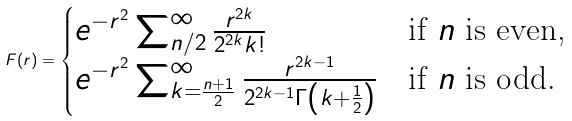<formula> <loc_0><loc_0><loc_500><loc_500>F ( r ) = \begin{cases} e ^ { - r ^ { 2 } } \sum _ { n / 2 } ^ { \infty } \frac { r ^ { 2 k } } { 2 ^ { 2 k } k ! } & \text {if $n$ is even,} \\ e ^ { - r ^ { 2 } } \sum _ { k = \frac { n + 1 } { 2 } } ^ { \infty } \frac { r ^ { 2 k - 1 } } { 2 ^ { 2 k - 1 } \Gamma \left ( k + \frac { 1 } { 2 } \right ) } & \text {if $n$ is odd.} \end{cases}</formula> 